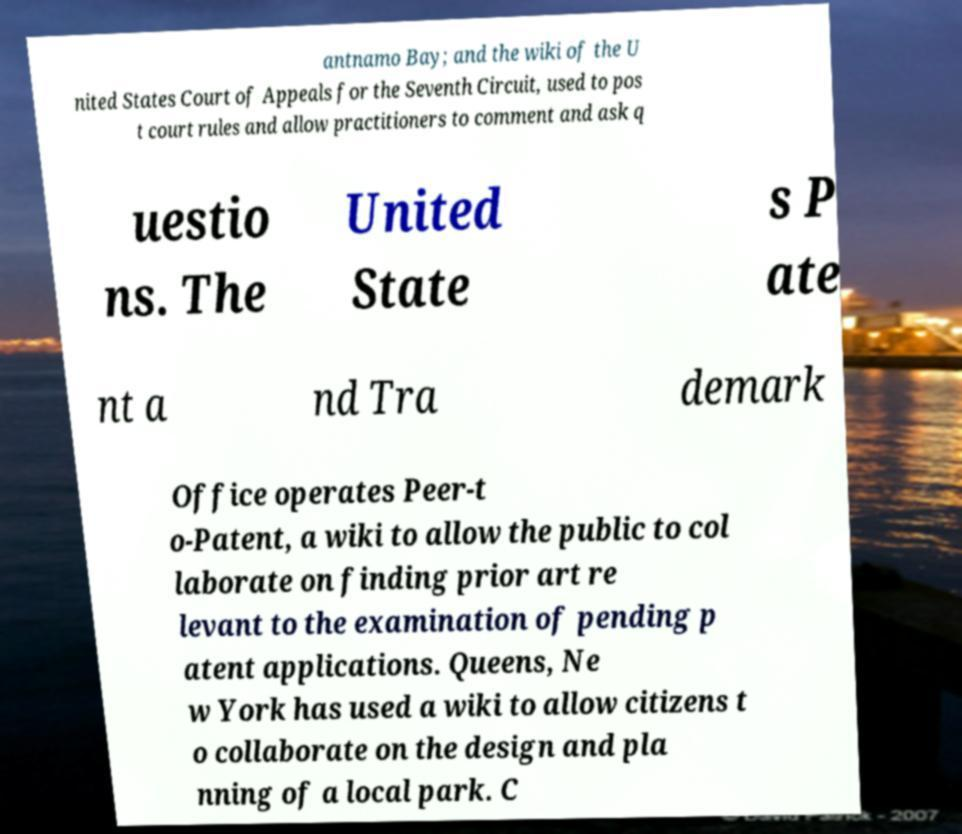What messages or text are displayed in this image? I need them in a readable, typed format. antnamo Bay; and the wiki of the U nited States Court of Appeals for the Seventh Circuit, used to pos t court rules and allow practitioners to comment and ask q uestio ns. The United State s P ate nt a nd Tra demark Office operates Peer-t o-Patent, a wiki to allow the public to col laborate on finding prior art re levant to the examination of pending p atent applications. Queens, Ne w York has used a wiki to allow citizens t o collaborate on the design and pla nning of a local park. C 